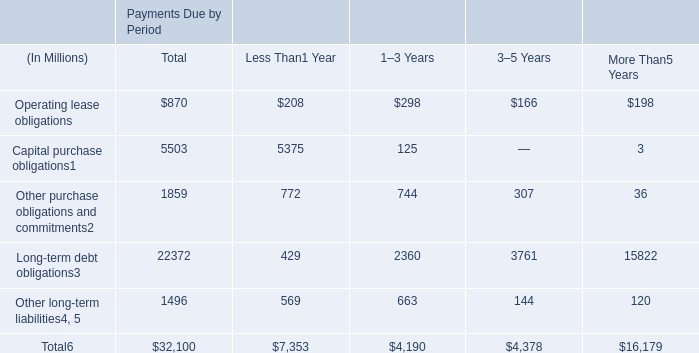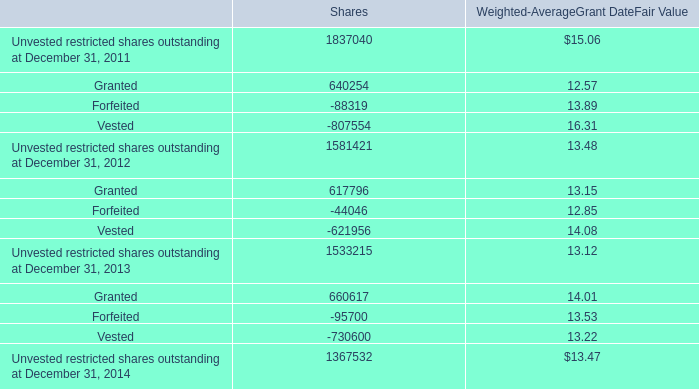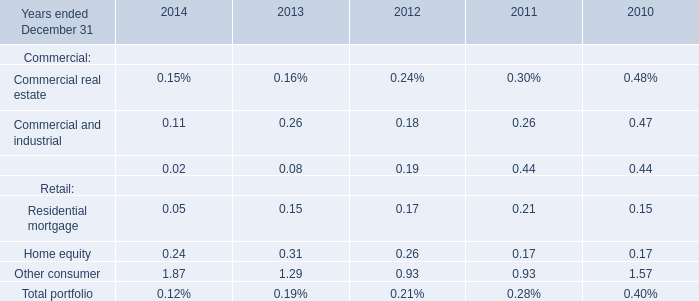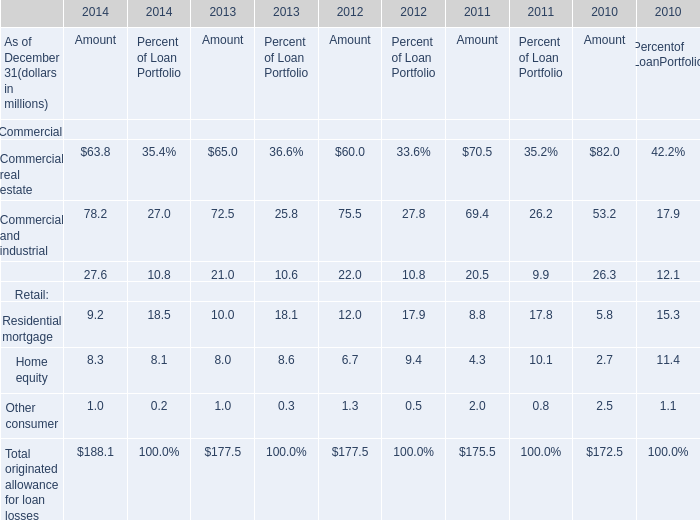What was the average value of the Commercial and industrial in the years where Commercial real estate is positive? (in million) 
Computations: (((((78.2 + 72.5) + 75.5) + 69.4) + 53.2) / 5)
Answer: 69.76. 